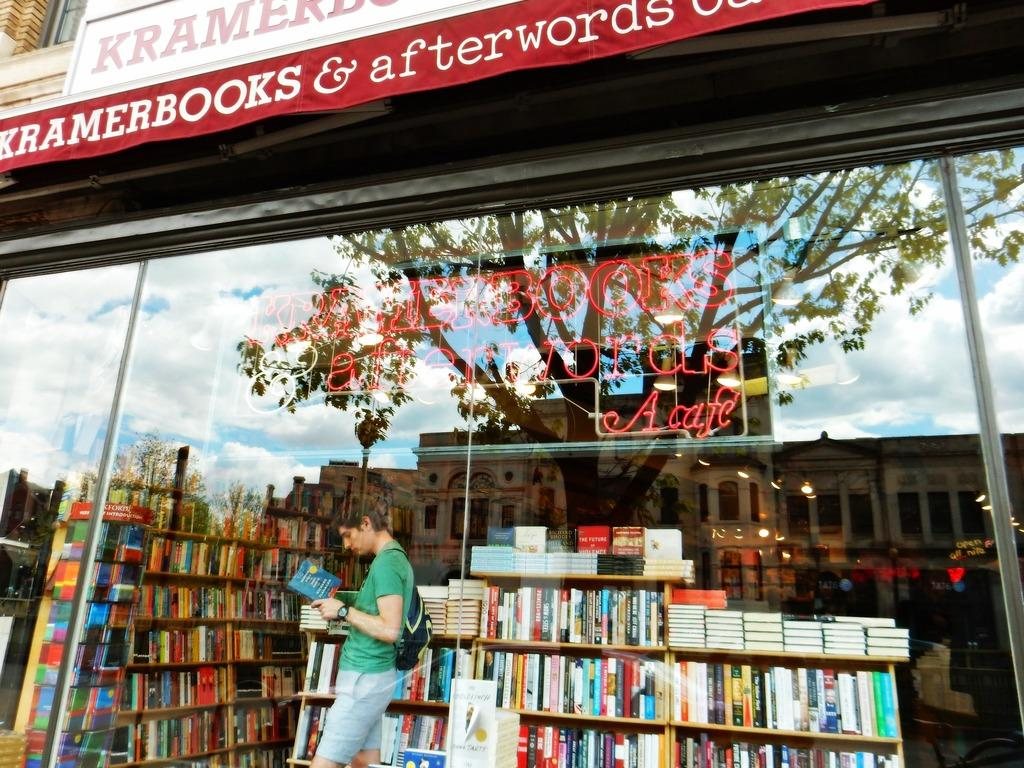<image>
Relay a brief, clear account of the picture shown. man reading a book in front of a store called Kramerbooks. 